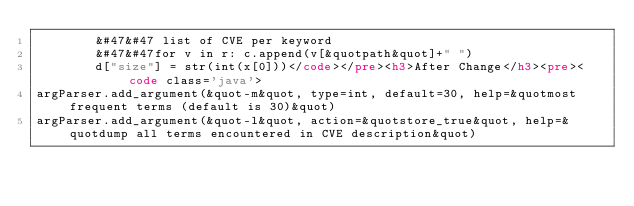<code> <loc_0><loc_0><loc_500><loc_500><_HTML_>        &#47&#47 list of CVE per keyword
        &#47&#47for v in r: c.append(v[&quotpath&quot]+" ")
        d["size"] = str(int(x[0]))</code></pre><h3>After Change</h3><pre><code class='java'>
argParser.add_argument(&quot-m&quot, type=int, default=30, help=&quotmost frequent terms (default is 30)&quot)
argParser.add_argument(&quot-l&quot, action=&quotstore_true&quot, help=&quotdump all terms encountered in CVE description&quot)</code> 